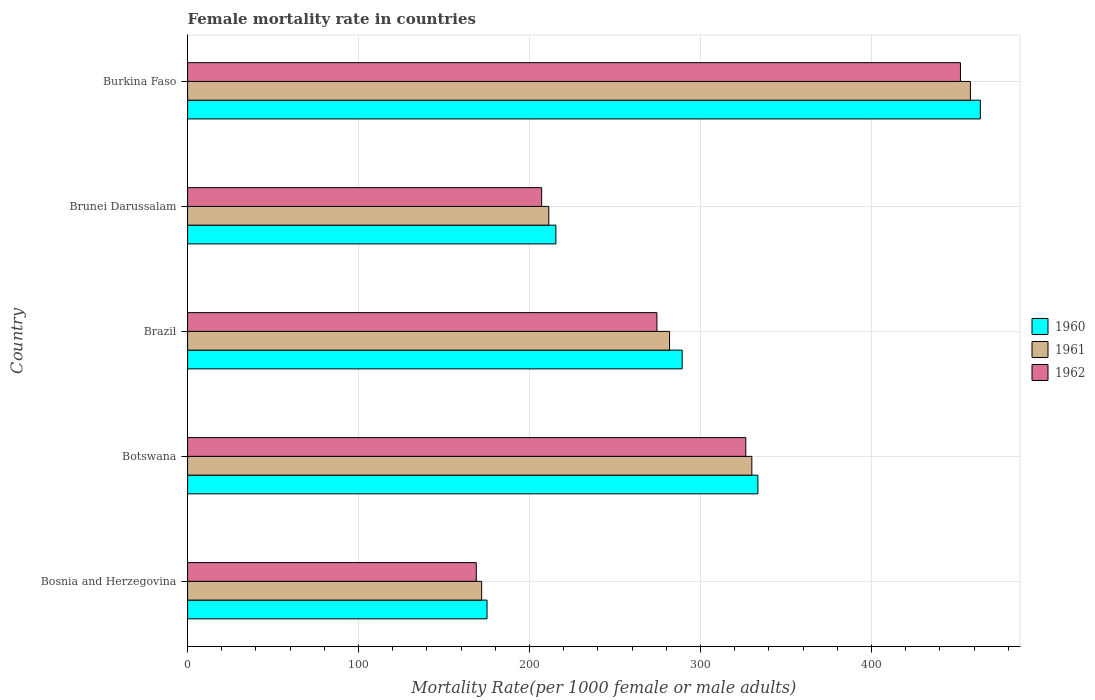Are the number of bars on each tick of the Y-axis equal?
Keep it short and to the point. Yes. How many bars are there on the 2nd tick from the top?
Offer a terse response. 3. How many bars are there on the 5th tick from the bottom?
Keep it short and to the point. 3. What is the label of the 3rd group of bars from the top?
Provide a succinct answer. Brazil. In how many cases, is the number of bars for a given country not equal to the number of legend labels?
Ensure brevity in your answer.  0. What is the female mortality rate in 1960 in Botswana?
Ensure brevity in your answer.  333.54. Across all countries, what is the maximum female mortality rate in 1962?
Ensure brevity in your answer.  452. Across all countries, what is the minimum female mortality rate in 1961?
Your answer should be very brief. 171.98. In which country was the female mortality rate in 1962 maximum?
Your answer should be very brief. Burkina Faso. In which country was the female mortality rate in 1961 minimum?
Keep it short and to the point. Bosnia and Herzegovina. What is the total female mortality rate in 1961 in the graph?
Make the answer very short. 1452.92. What is the difference between the female mortality rate in 1962 in Bosnia and Herzegovina and that in Brunei Darussalam?
Make the answer very short. -38.26. What is the difference between the female mortality rate in 1961 in Bosnia and Herzegovina and the female mortality rate in 1962 in Botswana?
Keep it short and to the point. -154.48. What is the average female mortality rate in 1962 per country?
Keep it short and to the point. 285.77. What is the difference between the female mortality rate in 1961 and female mortality rate in 1960 in Brunei Darussalam?
Make the answer very short. -4.16. What is the ratio of the female mortality rate in 1960 in Bosnia and Herzegovina to that in Burkina Faso?
Your response must be concise. 0.38. Is the female mortality rate in 1961 in Bosnia and Herzegovina less than that in Brazil?
Your answer should be compact. Yes. Is the difference between the female mortality rate in 1961 in Botswana and Burkina Faso greater than the difference between the female mortality rate in 1960 in Botswana and Burkina Faso?
Your answer should be very brief. Yes. What is the difference between the highest and the second highest female mortality rate in 1962?
Offer a very short reply. 125.55. What is the difference between the highest and the lowest female mortality rate in 1962?
Offer a very short reply. 283.18. Is the sum of the female mortality rate in 1961 in Brazil and Burkina Faso greater than the maximum female mortality rate in 1960 across all countries?
Provide a succinct answer. Yes. What does the 2nd bar from the top in Bosnia and Herzegovina represents?
Offer a very short reply. 1961. Is it the case that in every country, the sum of the female mortality rate in 1960 and female mortality rate in 1962 is greater than the female mortality rate in 1961?
Provide a short and direct response. Yes. Are all the bars in the graph horizontal?
Your answer should be compact. Yes. How many countries are there in the graph?
Keep it short and to the point. 5. Are the values on the major ticks of X-axis written in scientific E-notation?
Your answer should be compact. No. What is the title of the graph?
Make the answer very short. Female mortality rate in countries. Does "1996" appear as one of the legend labels in the graph?
Make the answer very short. No. What is the label or title of the X-axis?
Offer a very short reply. Mortality Rate(per 1000 female or male adults). What is the label or title of the Y-axis?
Offer a terse response. Country. What is the Mortality Rate(per 1000 female or male adults) of 1960 in Bosnia and Herzegovina?
Make the answer very short. 175.12. What is the Mortality Rate(per 1000 female or male adults) in 1961 in Bosnia and Herzegovina?
Offer a very short reply. 171.98. What is the Mortality Rate(per 1000 female or male adults) in 1962 in Bosnia and Herzegovina?
Make the answer very short. 168.83. What is the Mortality Rate(per 1000 female or male adults) in 1960 in Botswana?
Provide a short and direct response. 333.54. What is the Mortality Rate(per 1000 female or male adults) of 1961 in Botswana?
Your answer should be compact. 330. What is the Mortality Rate(per 1000 female or male adults) of 1962 in Botswana?
Offer a terse response. 326.45. What is the Mortality Rate(per 1000 female or male adults) of 1960 in Brazil?
Keep it short and to the point. 289.25. What is the Mortality Rate(per 1000 female or male adults) of 1961 in Brazil?
Make the answer very short. 281.87. What is the Mortality Rate(per 1000 female or male adults) in 1962 in Brazil?
Your answer should be very brief. 274.49. What is the Mortality Rate(per 1000 female or male adults) in 1960 in Brunei Darussalam?
Your answer should be compact. 215.4. What is the Mortality Rate(per 1000 female or male adults) of 1961 in Brunei Darussalam?
Provide a succinct answer. 211.24. What is the Mortality Rate(per 1000 female or male adults) in 1962 in Brunei Darussalam?
Keep it short and to the point. 207.09. What is the Mortality Rate(per 1000 female or male adults) of 1960 in Burkina Faso?
Your answer should be very brief. 463.65. What is the Mortality Rate(per 1000 female or male adults) in 1961 in Burkina Faso?
Provide a succinct answer. 457.83. What is the Mortality Rate(per 1000 female or male adults) of 1962 in Burkina Faso?
Offer a very short reply. 452. Across all countries, what is the maximum Mortality Rate(per 1000 female or male adults) of 1960?
Keep it short and to the point. 463.65. Across all countries, what is the maximum Mortality Rate(per 1000 female or male adults) of 1961?
Your answer should be compact. 457.83. Across all countries, what is the maximum Mortality Rate(per 1000 female or male adults) in 1962?
Your response must be concise. 452. Across all countries, what is the minimum Mortality Rate(per 1000 female or male adults) of 1960?
Your response must be concise. 175.12. Across all countries, what is the minimum Mortality Rate(per 1000 female or male adults) of 1961?
Provide a short and direct response. 171.98. Across all countries, what is the minimum Mortality Rate(per 1000 female or male adults) of 1962?
Your response must be concise. 168.83. What is the total Mortality Rate(per 1000 female or male adults) in 1960 in the graph?
Keep it short and to the point. 1476.97. What is the total Mortality Rate(per 1000 female or male adults) in 1961 in the graph?
Give a very brief answer. 1452.92. What is the total Mortality Rate(per 1000 female or male adults) in 1962 in the graph?
Provide a succinct answer. 1428.86. What is the difference between the Mortality Rate(per 1000 female or male adults) in 1960 in Bosnia and Herzegovina and that in Botswana?
Provide a short and direct response. -158.42. What is the difference between the Mortality Rate(per 1000 female or male adults) in 1961 in Bosnia and Herzegovina and that in Botswana?
Your answer should be compact. -158.02. What is the difference between the Mortality Rate(per 1000 female or male adults) in 1962 in Bosnia and Herzegovina and that in Botswana?
Offer a terse response. -157.62. What is the difference between the Mortality Rate(per 1000 female or male adults) in 1960 in Bosnia and Herzegovina and that in Brazil?
Give a very brief answer. -114.13. What is the difference between the Mortality Rate(per 1000 female or male adults) in 1961 in Bosnia and Herzegovina and that in Brazil?
Give a very brief answer. -109.9. What is the difference between the Mortality Rate(per 1000 female or male adults) of 1962 in Bosnia and Herzegovina and that in Brazil?
Make the answer very short. -105.66. What is the difference between the Mortality Rate(per 1000 female or male adults) in 1960 in Bosnia and Herzegovina and that in Brunei Darussalam?
Your answer should be compact. -40.27. What is the difference between the Mortality Rate(per 1000 female or male adults) of 1961 in Bosnia and Herzegovina and that in Brunei Darussalam?
Make the answer very short. -39.27. What is the difference between the Mortality Rate(per 1000 female or male adults) in 1962 in Bosnia and Herzegovina and that in Brunei Darussalam?
Your response must be concise. -38.26. What is the difference between the Mortality Rate(per 1000 female or male adults) of 1960 in Bosnia and Herzegovina and that in Burkina Faso?
Your answer should be very brief. -288.52. What is the difference between the Mortality Rate(per 1000 female or male adults) in 1961 in Bosnia and Herzegovina and that in Burkina Faso?
Make the answer very short. -285.85. What is the difference between the Mortality Rate(per 1000 female or male adults) of 1962 in Bosnia and Herzegovina and that in Burkina Faso?
Ensure brevity in your answer.  -283.18. What is the difference between the Mortality Rate(per 1000 female or male adults) in 1960 in Botswana and that in Brazil?
Your response must be concise. 44.29. What is the difference between the Mortality Rate(per 1000 female or male adults) of 1961 in Botswana and that in Brazil?
Ensure brevity in your answer.  48.13. What is the difference between the Mortality Rate(per 1000 female or male adults) of 1962 in Botswana and that in Brazil?
Keep it short and to the point. 51.96. What is the difference between the Mortality Rate(per 1000 female or male adults) in 1960 in Botswana and that in Brunei Darussalam?
Provide a succinct answer. 118.14. What is the difference between the Mortality Rate(per 1000 female or male adults) in 1961 in Botswana and that in Brunei Darussalam?
Offer a terse response. 118.76. What is the difference between the Mortality Rate(per 1000 female or male adults) of 1962 in Botswana and that in Brunei Darussalam?
Offer a very short reply. 119.37. What is the difference between the Mortality Rate(per 1000 female or male adults) of 1960 in Botswana and that in Burkina Faso?
Offer a very short reply. -130.1. What is the difference between the Mortality Rate(per 1000 female or male adults) in 1961 in Botswana and that in Burkina Faso?
Give a very brief answer. -127.83. What is the difference between the Mortality Rate(per 1000 female or male adults) in 1962 in Botswana and that in Burkina Faso?
Your answer should be very brief. -125.55. What is the difference between the Mortality Rate(per 1000 female or male adults) in 1960 in Brazil and that in Brunei Darussalam?
Offer a very short reply. 73.86. What is the difference between the Mortality Rate(per 1000 female or male adults) in 1961 in Brazil and that in Brunei Darussalam?
Ensure brevity in your answer.  70.63. What is the difference between the Mortality Rate(per 1000 female or male adults) in 1962 in Brazil and that in Brunei Darussalam?
Your answer should be compact. 67.41. What is the difference between the Mortality Rate(per 1000 female or male adults) in 1960 in Brazil and that in Burkina Faso?
Give a very brief answer. -174.39. What is the difference between the Mortality Rate(per 1000 female or male adults) of 1961 in Brazil and that in Burkina Faso?
Offer a very short reply. -175.95. What is the difference between the Mortality Rate(per 1000 female or male adults) of 1962 in Brazil and that in Burkina Faso?
Make the answer very short. -177.51. What is the difference between the Mortality Rate(per 1000 female or male adults) in 1960 in Brunei Darussalam and that in Burkina Faso?
Offer a terse response. -248.25. What is the difference between the Mortality Rate(per 1000 female or male adults) in 1961 in Brunei Darussalam and that in Burkina Faso?
Your response must be concise. -246.58. What is the difference between the Mortality Rate(per 1000 female or male adults) in 1962 in Brunei Darussalam and that in Burkina Faso?
Provide a short and direct response. -244.92. What is the difference between the Mortality Rate(per 1000 female or male adults) in 1960 in Bosnia and Herzegovina and the Mortality Rate(per 1000 female or male adults) in 1961 in Botswana?
Keep it short and to the point. -154.88. What is the difference between the Mortality Rate(per 1000 female or male adults) of 1960 in Bosnia and Herzegovina and the Mortality Rate(per 1000 female or male adults) of 1962 in Botswana?
Ensure brevity in your answer.  -151.33. What is the difference between the Mortality Rate(per 1000 female or male adults) in 1961 in Bosnia and Herzegovina and the Mortality Rate(per 1000 female or male adults) in 1962 in Botswana?
Your answer should be compact. -154.48. What is the difference between the Mortality Rate(per 1000 female or male adults) in 1960 in Bosnia and Herzegovina and the Mortality Rate(per 1000 female or male adults) in 1961 in Brazil?
Give a very brief answer. -106.75. What is the difference between the Mortality Rate(per 1000 female or male adults) of 1960 in Bosnia and Herzegovina and the Mortality Rate(per 1000 female or male adults) of 1962 in Brazil?
Your response must be concise. -99.37. What is the difference between the Mortality Rate(per 1000 female or male adults) in 1961 in Bosnia and Herzegovina and the Mortality Rate(per 1000 female or male adults) in 1962 in Brazil?
Offer a terse response. -102.52. What is the difference between the Mortality Rate(per 1000 female or male adults) in 1960 in Bosnia and Herzegovina and the Mortality Rate(per 1000 female or male adults) in 1961 in Brunei Darussalam?
Your response must be concise. -36.12. What is the difference between the Mortality Rate(per 1000 female or male adults) in 1960 in Bosnia and Herzegovina and the Mortality Rate(per 1000 female or male adults) in 1962 in Brunei Darussalam?
Give a very brief answer. -31.96. What is the difference between the Mortality Rate(per 1000 female or male adults) of 1961 in Bosnia and Herzegovina and the Mortality Rate(per 1000 female or male adults) of 1962 in Brunei Darussalam?
Ensure brevity in your answer.  -35.11. What is the difference between the Mortality Rate(per 1000 female or male adults) of 1960 in Bosnia and Herzegovina and the Mortality Rate(per 1000 female or male adults) of 1961 in Burkina Faso?
Your answer should be very brief. -282.7. What is the difference between the Mortality Rate(per 1000 female or male adults) of 1960 in Bosnia and Herzegovina and the Mortality Rate(per 1000 female or male adults) of 1962 in Burkina Faso?
Ensure brevity in your answer.  -276.88. What is the difference between the Mortality Rate(per 1000 female or male adults) in 1961 in Bosnia and Herzegovina and the Mortality Rate(per 1000 female or male adults) in 1962 in Burkina Faso?
Your answer should be very brief. -280.03. What is the difference between the Mortality Rate(per 1000 female or male adults) of 1960 in Botswana and the Mortality Rate(per 1000 female or male adults) of 1961 in Brazil?
Provide a succinct answer. 51.67. What is the difference between the Mortality Rate(per 1000 female or male adults) of 1960 in Botswana and the Mortality Rate(per 1000 female or male adults) of 1962 in Brazil?
Offer a terse response. 59.05. What is the difference between the Mortality Rate(per 1000 female or male adults) in 1961 in Botswana and the Mortality Rate(per 1000 female or male adults) in 1962 in Brazil?
Provide a short and direct response. 55.51. What is the difference between the Mortality Rate(per 1000 female or male adults) of 1960 in Botswana and the Mortality Rate(per 1000 female or male adults) of 1961 in Brunei Darussalam?
Provide a short and direct response. 122.3. What is the difference between the Mortality Rate(per 1000 female or male adults) in 1960 in Botswana and the Mortality Rate(per 1000 female or male adults) in 1962 in Brunei Darussalam?
Offer a very short reply. 126.46. What is the difference between the Mortality Rate(per 1000 female or male adults) of 1961 in Botswana and the Mortality Rate(per 1000 female or male adults) of 1962 in Brunei Darussalam?
Provide a succinct answer. 122.91. What is the difference between the Mortality Rate(per 1000 female or male adults) in 1960 in Botswana and the Mortality Rate(per 1000 female or male adults) in 1961 in Burkina Faso?
Your response must be concise. -124.28. What is the difference between the Mortality Rate(per 1000 female or male adults) in 1960 in Botswana and the Mortality Rate(per 1000 female or male adults) in 1962 in Burkina Faso?
Make the answer very short. -118.46. What is the difference between the Mortality Rate(per 1000 female or male adults) in 1961 in Botswana and the Mortality Rate(per 1000 female or male adults) in 1962 in Burkina Faso?
Keep it short and to the point. -122.01. What is the difference between the Mortality Rate(per 1000 female or male adults) of 1960 in Brazil and the Mortality Rate(per 1000 female or male adults) of 1961 in Brunei Darussalam?
Give a very brief answer. 78.01. What is the difference between the Mortality Rate(per 1000 female or male adults) in 1960 in Brazil and the Mortality Rate(per 1000 female or male adults) in 1962 in Brunei Darussalam?
Ensure brevity in your answer.  82.17. What is the difference between the Mortality Rate(per 1000 female or male adults) of 1961 in Brazil and the Mortality Rate(per 1000 female or male adults) of 1962 in Brunei Darussalam?
Give a very brief answer. 74.79. What is the difference between the Mortality Rate(per 1000 female or male adults) in 1960 in Brazil and the Mortality Rate(per 1000 female or male adults) in 1961 in Burkina Faso?
Provide a short and direct response. -168.57. What is the difference between the Mortality Rate(per 1000 female or male adults) in 1960 in Brazil and the Mortality Rate(per 1000 female or male adults) in 1962 in Burkina Faso?
Make the answer very short. -162.75. What is the difference between the Mortality Rate(per 1000 female or male adults) in 1961 in Brazil and the Mortality Rate(per 1000 female or male adults) in 1962 in Burkina Faso?
Provide a succinct answer. -170.13. What is the difference between the Mortality Rate(per 1000 female or male adults) of 1960 in Brunei Darussalam and the Mortality Rate(per 1000 female or male adults) of 1961 in Burkina Faso?
Give a very brief answer. -242.43. What is the difference between the Mortality Rate(per 1000 female or male adults) of 1960 in Brunei Darussalam and the Mortality Rate(per 1000 female or male adults) of 1962 in Burkina Faso?
Keep it short and to the point. -236.61. What is the difference between the Mortality Rate(per 1000 female or male adults) of 1961 in Brunei Darussalam and the Mortality Rate(per 1000 female or male adults) of 1962 in Burkina Faso?
Your answer should be very brief. -240.76. What is the average Mortality Rate(per 1000 female or male adults) of 1960 per country?
Make the answer very short. 295.39. What is the average Mortality Rate(per 1000 female or male adults) of 1961 per country?
Keep it short and to the point. 290.58. What is the average Mortality Rate(per 1000 female or male adults) in 1962 per country?
Ensure brevity in your answer.  285.77. What is the difference between the Mortality Rate(per 1000 female or male adults) in 1960 and Mortality Rate(per 1000 female or male adults) in 1961 in Bosnia and Herzegovina?
Ensure brevity in your answer.  3.15. What is the difference between the Mortality Rate(per 1000 female or male adults) of 1960 and Mortality Rate(per 1000 female or male adults) of 1962 in Bosnia and Herzegovina?
Give a very brief answer. 6.29. What is the difference between the Mortality Rate(per 1000 female or male adults) in 1961 and Mortality Rate(per 1000 female or male adults) in 1962 in Bosnia and Herzegovina?
Keep it short and to the point. 3.15. What is the difference between the Mortality Rate(per 1000 female or male adults) of 1960 and Mortality Rate(per 1000 female or male adults) of 1961 in Botswana?
Offer a terse response. 3.54. What is the difference between the Mortality Rate(per 1000 female or male adults) of 1960 and Mortality Rate(per 1000 female or male adults) of 1962 in Botswana?
Your answer should be compact. 7.09. What is the difference between the Mortality Rate(per 1000 female or male adults) in 1961 and Mortality Rate(per 1000 female or male adults) in 1962 in Botswana?
Your response must be concise. 3.54. What is the difference between the Mortality Rate(per 1000 female or male adults) in 1960 and Mortality Rate(per 1000 female or male adults) in 1961 in Brazil?
Provide a short and direct response. 7.38. What is the difference between the Mortality Rate(per 1000 female or male adults) in 1960 and Mortality Rate(per 1000 female or male adults) in 1962 in Brazil?
Offer a very short reply. 14.76. What is the difference between the Mortality Rate(per 1000 female or male adults) of 1961 and Mortality Rate(per 1000 female or male adults) of 1962 in Brazil?
Provide a succinct answer. 7.38. What is the difference between the Mortality Rate(per 1000 female or male adults) of 1960 and Mortality Rate(per 1000 female or male adults) of 1961 in Brunei Darussalam?
Your response must be concise. 4.16. What is the difference between the Mortality Rate(per 1000 female or male adults) of 1960 and Mortality Rate(per 1000 female or male adults) of 1962 in Brunei Darussalam?
Give a very brief answer. 8.31. What is the difference between the Mortality Rate(per 1000 female or male adults) of 1961 and Mortality Rate(per 1000 female or male adults) of 1962 in Brunei Darussalam?
Offer a very short reply. 4.16. What is the difference between the Mortality Rate(per 1000 female or male adults) in 1960 and Mortality Rate(per 1000 female or male adults) in 1961 in Burkina Faso?
Offer a terse response. 5.82. What is the difference between the Mortality Rate(per 1000 female or male adults) in 1960 and Mortality Rate(per 1000 female or male adults) in 1962 in Burkina Faso?
Provide a short and direct response. 11.64. What is the difference between the Mortality Rate(per 1000 female or male adults) in 1961 and Mortality Rate(per 1000 female or male adults) in 1962 in Burkina Faso?
Give a very brief answer. 5.82. What is the ratio of the Mortality Rate(per 1000 female or male adults) in 1960 in Bosnia and Herzegovina to that in Botswana?
Provide a short and direct response. 0.53. What is the ratio of the Mortality Rate(per 1000 female or male adults) of 1961 in Bosnia and Herzegovina to that in Botswana?
Your answer should be very brief. 0.52. What is the ratio of the Mortality Rate(per 1000 female or male adults) in 1962 in Bosnia and Herzegovina to that in Botswana?
Your answer should be compact. 0.52. What is the ratio of the Mortality Rate(per 1000 female or male adults) of 1960 in Bosnia and Herzegovina to that in Brazil?
Give a very brief answer. 0.61. What is the ratio of the Mortality Rate(per 1000 female or male adults) in 1961 in Bosnia and Herzegovina to that in Brazil?
Make the answer very short. 0.61. What is the ratio of the Mortality Rate(per 1000 female or male adults) of 1962 in Bosnia and Herzegovina to that in Brazil?
Provide a succinct answer. 0.62. What is the ratio of the Mortality Rate(per 1000 female or male adults) of 1960 in Bosnia and Herzegovina to that in Brunei Darussalam?
Offer a terse response. 0.81. What is the ratio of the Mortality Rate(per 1000 female or male adults) of 1961 in Bosnia and Herzegovina to that in Brunei Darussalam?
Offer a very short reply. 0.81. What is the ratio of the Mortality Rate(per 1000 female or male adults) in 1962 in Bosnia and Herzegovina to that in Brunei Darussalam?
Provide a succinct answer. 0.82. What is the ratio of the Mortality Rate(per 1000 female or male adults) of 1960 in Bosnia and Herzegovina to that in Burkina Faso?
Give a very brief answer. 0.38. What is the ratio of the Mortality Rate(per 1000 female or male adults) in 1961 in Bosnia and Herzegovina to that in Burkina Faso?
Your response must be concise. 0.38. What is the ratio of the Mortality Rate(per 1000 female or male adults) in 1962 in Bosnia and Herzegovina to that in Burkina Faso?
Offer a terse response. 0.37. What is the ratio of the Mortality Rate(per 1000 female or male adults) in 1960 in Botswana to that in Brazil?
Offer a very short reply. 1.15. What is the ratio of the Mortality Rate(per 1000 female or male adults) in 1961 in Botswana to that in Brazil?
Offer a terse response. 1.17. What is the ratio of the Mortality Rate(per 1000 female or male adults) in 1962 in Botswana to that in Brazil?
Give a very brief answer. 1.19. What is the ratio of the Mortality Rate(per 1000 female or male adults) of 1960 in Botswana to that in Brunei Darussalam?
Provide a short and direct response. 1.55. What is the ratio of the Mortality Rate(per 1000 female or male adults) in 1961 in Botswana to that in Brunei Darussalam?
Your response must be concise. 1.56. What is the ratio of the Mortality Rate(per 1000 female or male adults) of 1962 in Botswana to that in Brunei Darussalam?
Ensure brevity in your answer.  1.58. What is the ratio of the Mortality Rate(per 1000 female or male adults) in 1960 in Botswana to that in Burkina Faso?
Offer a very short reply. 0.72. What is the ratio of the Mortality Rate(per 1000 female or male adults) of 1961 in Botswana to that in Burkina Faso?
Give a very brief answer. 0.72. What is the ratio of the Mortality Rate(per 1000 female or male adults) in 1962 in Botswana to that in Burkina Faso?
Your answer should be compact. 0.72. What is the ratio of the Mortality Rate(per 1000 female or male adults) in 1960 in Brazil to that in Brunei Darussalam?
Give a very brief answer. 1.34. What is the ratio of the Mortality Rate(per 1000 female or male adults) of 1961 in Brazil to that in Brunei Darussalam?
Ensure brevity in your answer.  1.33. What is the ratio of the Mortality Rate(per 1000 female or male adults) in 1962 in Brazil to that in Brunei Darussalam?
Your answer should be very brief. 1.33. What is the ratio of the Mortality Rate(per 1000 female or male adults) of 1960 in Brazil to that in Burkina Faso?
Your answer should be very brief. 0.62. What is the ratio of the Mortality Rate(per 1000 female or male adults) in 1961 in Brazil to that in Burkina Faso?
Make the answer very short. 0.62. What is the ratio of the Mortality Rate(per 1000 female or male adults) in 1962 in Brazil to that in Burkina Faso?
Ensure brevity in your answer.  0.61. What is the ratio of the Mortality Rate(per 1000 female or male adults) in 1960 in Brunei Darussalam to that in Burkina Faso?
Provide a short and direct response. 0.46. What is the ratio of the Mortality Rate(per 1000 female or male adults) in 1961 in Brunei Darussalam to that in Burkina Faso?
Keep it short and to the point. 0.46. What is the ratio of the Mortality Rate(per 1000 female or male adults) of 1962 in Brunei Darussalam to that in Burkina Faso?
Offer a very short reply. 0.46. What is the difference between the highest and the second highest Mortality Rate(per 1000 female or male adults) in 1960?
Offer a terse response. 130.1. What is the difference between the highest and the second highest Mortality Rate(per 1000 female or male adults) of 1961?
Provide a short and direct response. 127.83. What is the difference between the highest and the second highest Mortality Rate(per 1000 female or male adults) of 1962?
Make the answer very short. 125.55. What is the difference between the highest and the lowest Mortality Rate(per 1000 female or male adults) in 1960?
Your answer should be very brief. 288.52. What is the difference between the highest and the lowest Mortality Rate(per 1000 female or male adults) of 1961?
Keep it short and to the point. 285.85. What is the difference between the highest and the lowest Mortality Rate(per 1000 female or male adults) of 1962?
Provide a succinct answer. 283.18. 